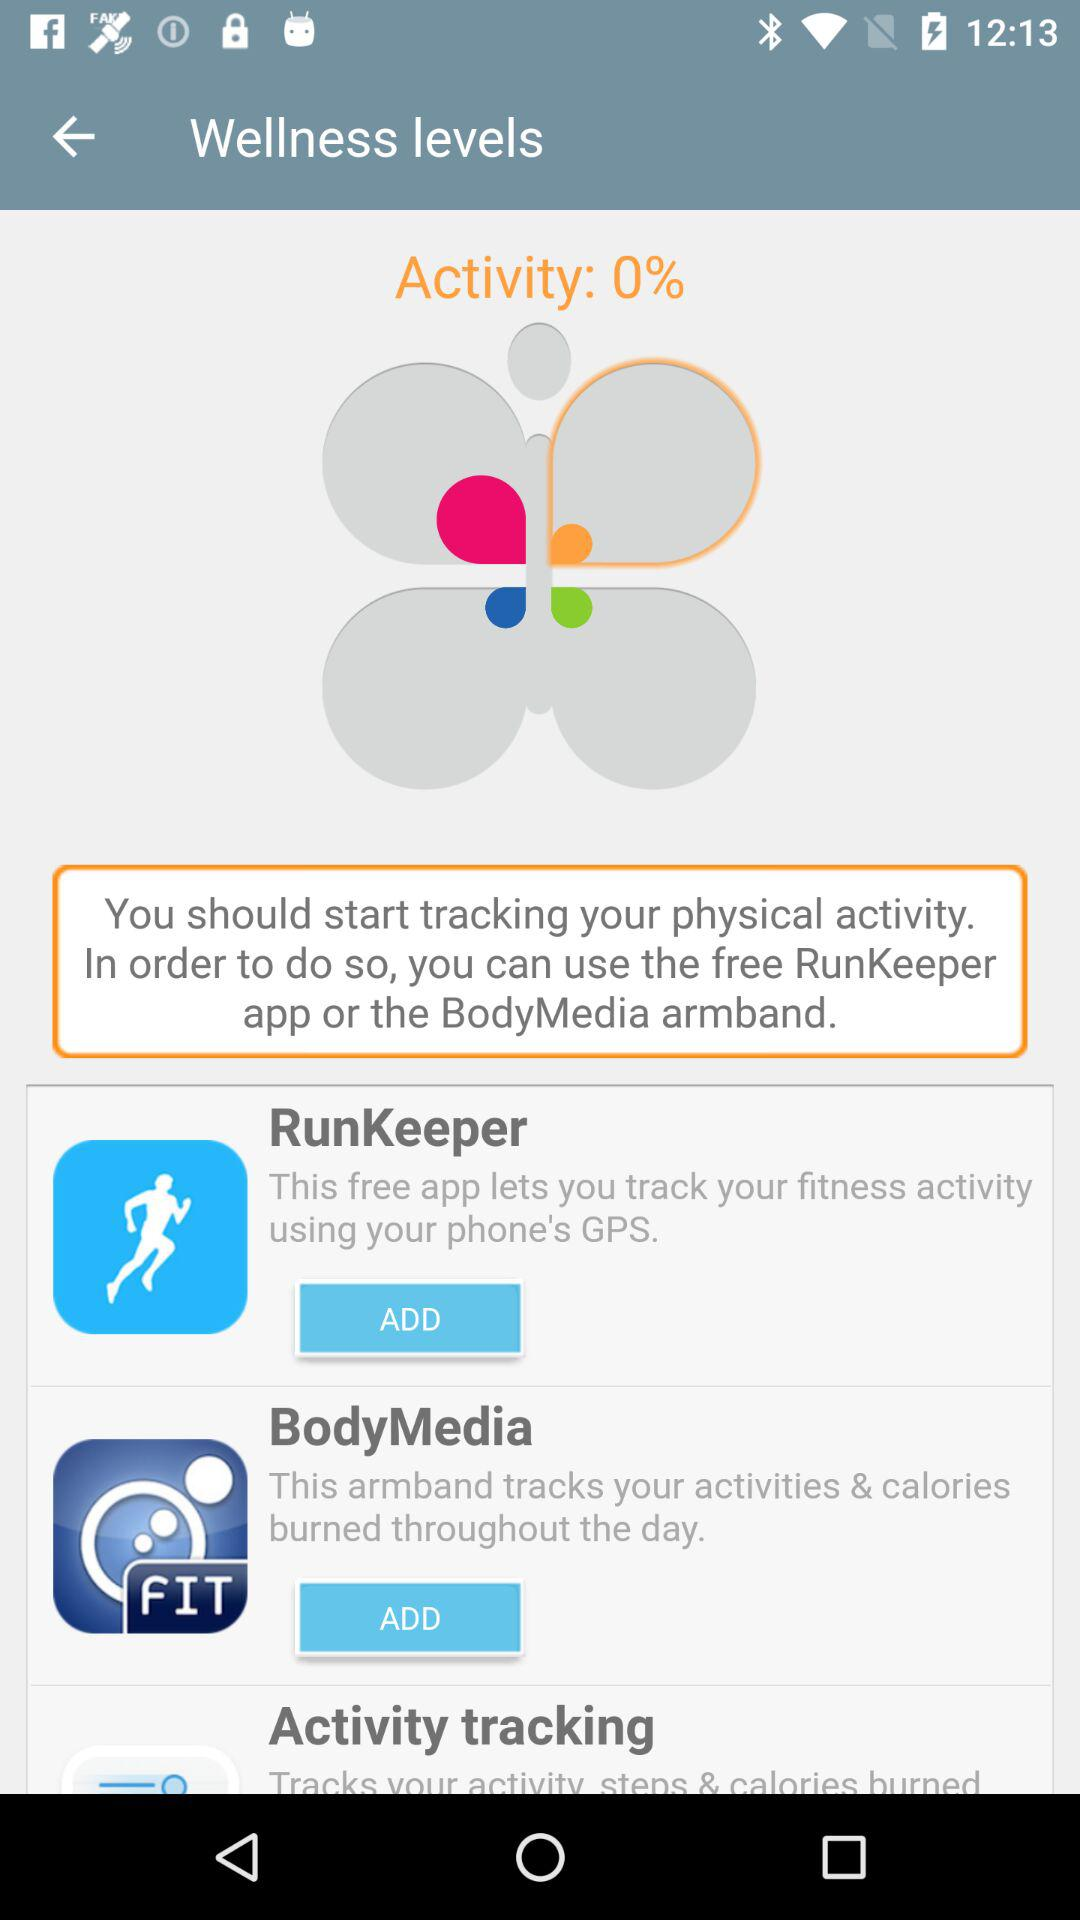What is the activity percentage shown here?
Answer the question using a single word or phrase. The activity percentage is 0% 